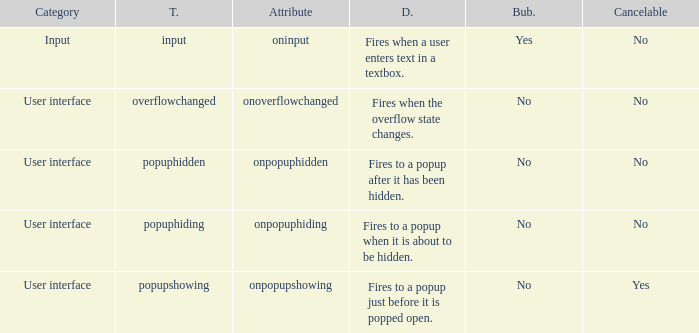 how many bubbles with category being input 1.0. 